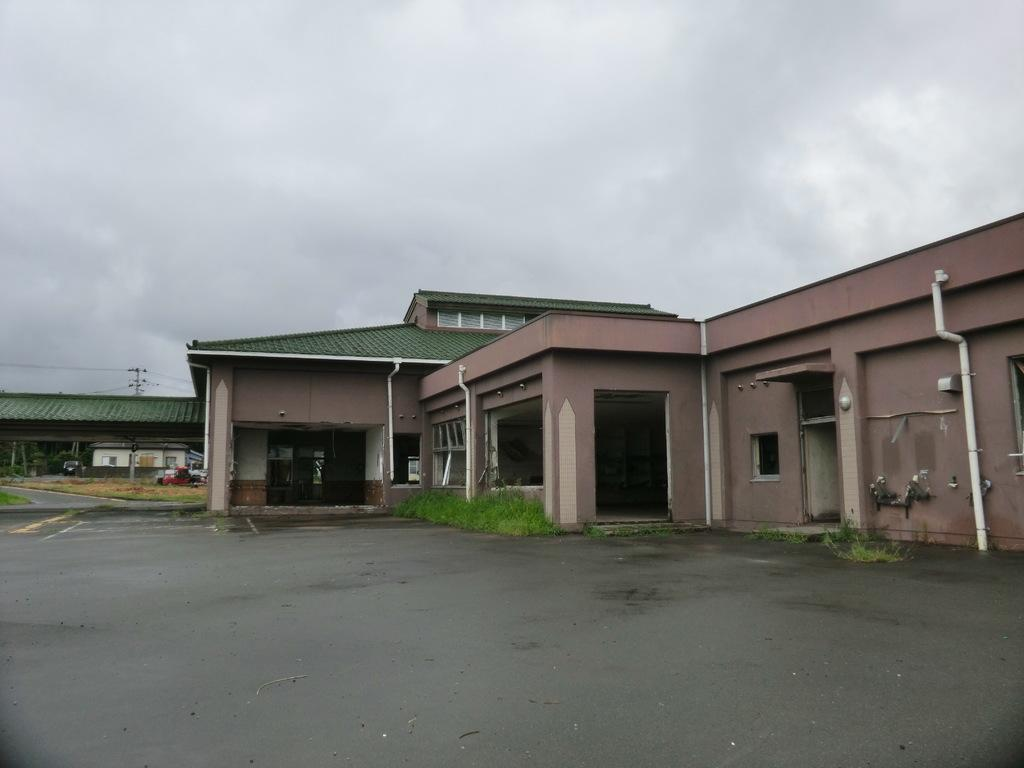What type of surface can be seen in the image? There is a road in the image. What type of vegetation is present in the image? There is grass in the image. What type of structures can be seen in the image? There are buildings in the image. What type of infrastructure is visible in the image? There are pipes in the image. What is visible in the background of the image? The sky is visible in the background of the image. What can be seen in the sky? Clouds are present in the sky. How many wings can be seen on the ear in the image? There is no ear or wing present in the image. What type of step is visible in the image? There is no step present in the image. 